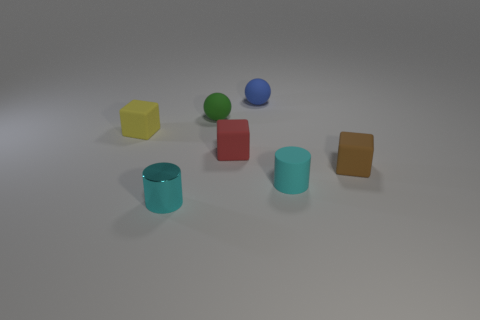Subtract all tiny brown rubber cubes. How many cubes are left? 2 Add 2 tiny matte balls. How many objects exist? 9 Subtract all balls. How many objects are left? 5 Subtract all green blocks. Subtract all cyan spheres. How many blocks are left? 3 Add 7 rubber cylinders. How many rubber cylinders are left? 8 Add 2 balls. How many balls exist? 4 Subtract 0 red balls. How many objects are left? 7 Subtract all green rubber things. Subtract all green rubber balls. How many objects are left? 5 